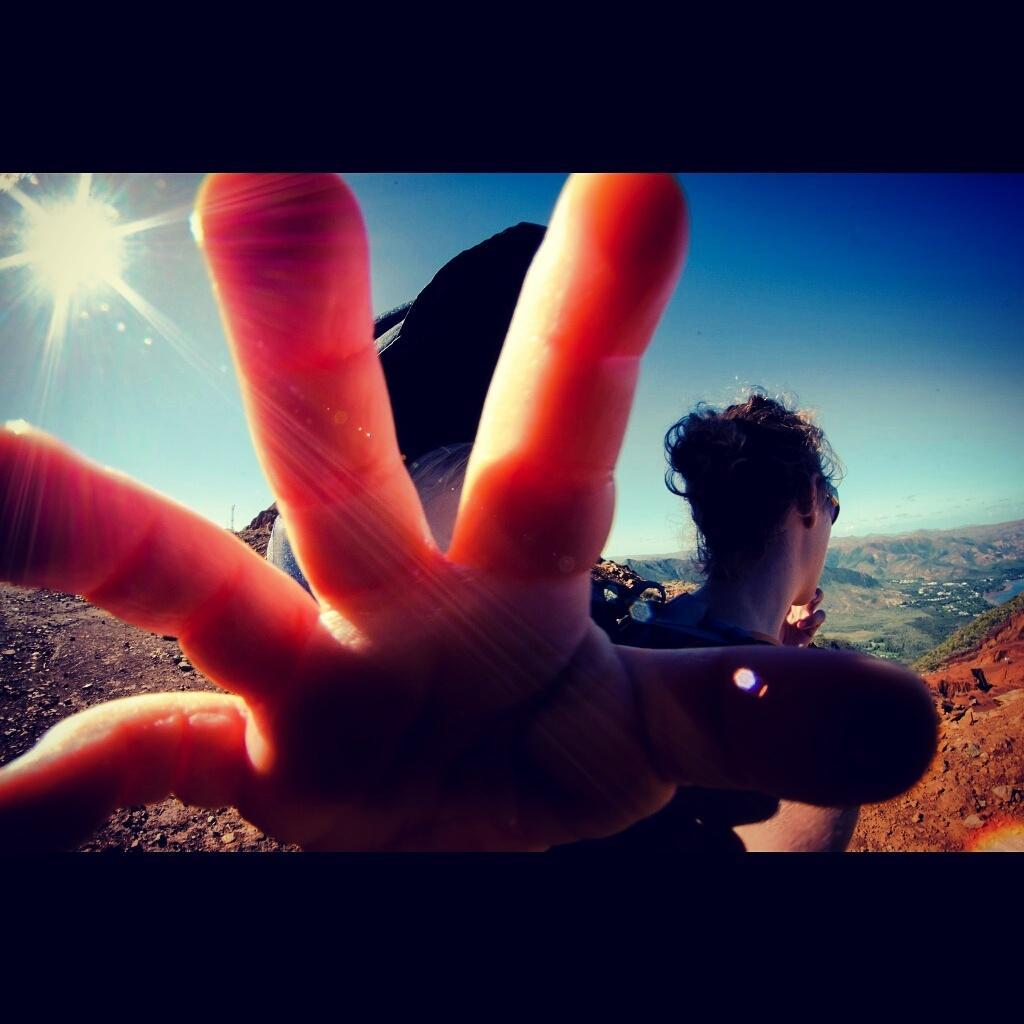Describe this image in one or two sentences. In this image we can see a lady person's hand and in the background of the image there are some mountains and top of the image there is clear sky. 